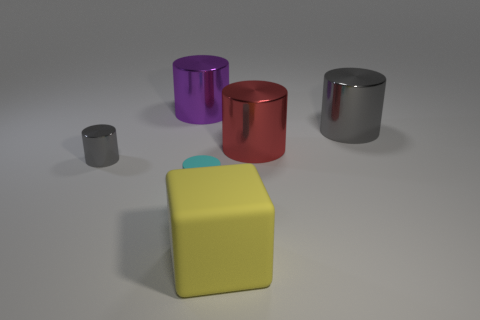What could be the purpose of this arrangement? Is it purely aesthetic or does it serve a functional purpose? This arrangement seems to be designed with aesthetics in mind, creating a pleasing gradient of sizes and a pop of contrasting color and shape with the yellow cube. It's likely part of a visual composition rather than serving a functional purpose.  Suppose these objects could interact, what kind of story could they tell? If these objects could interact, one might imagine them as characters in a story about diversity and unity. The cylinders could represent individuals who, despite their differences in size and color, align in harmony. The yellow cube, with its unique shape, could symbolize the idea that even the most distinct among us has a place in the community. 